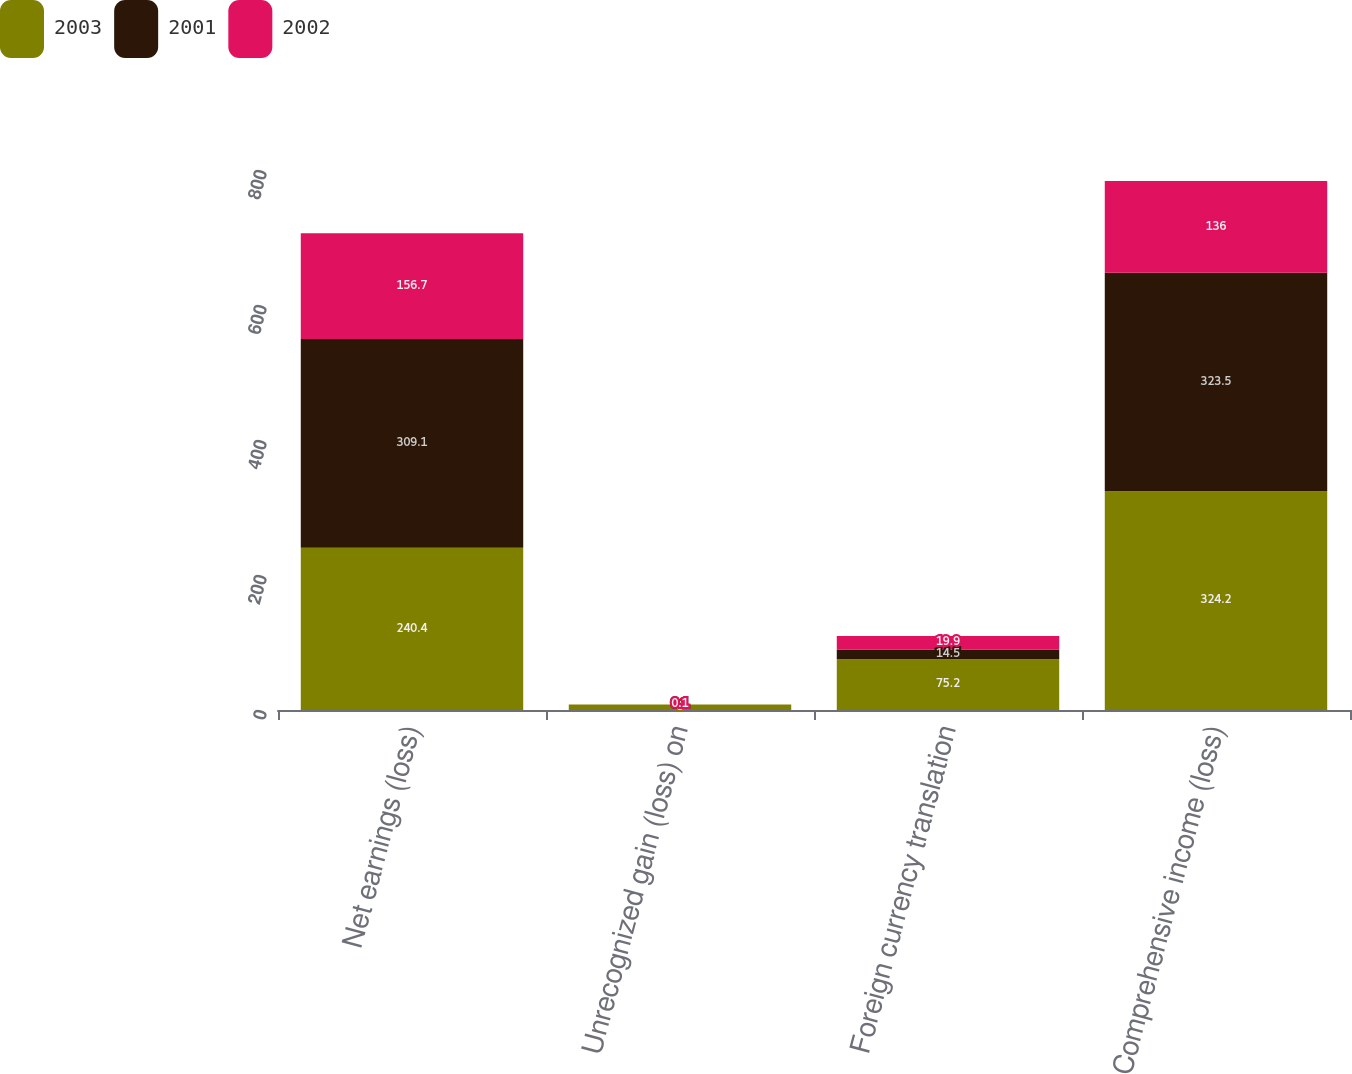Convert chart to OTSL. <chart><loc_0><loc_0><loc_500><loc_500><stacked_bar_chart><ecel><fcel>Net earnings (loss)<fcel>Unrecognized gain (loss) on<fcel>Foreign currency translation<fcel>Comprehensive income (loss)<nl><fcel>2003<fcel>240.4<fcel>8<fcel>75.2<fcel>324.2<nl><fcel>2001<fcel>309.1<fcel>0.1<fcel>14.5<fcel>323.5<nl><fcel>2002<fcel>156.7<fcel>0.1<fcel>19.9<fcel>136<nl></chart> 